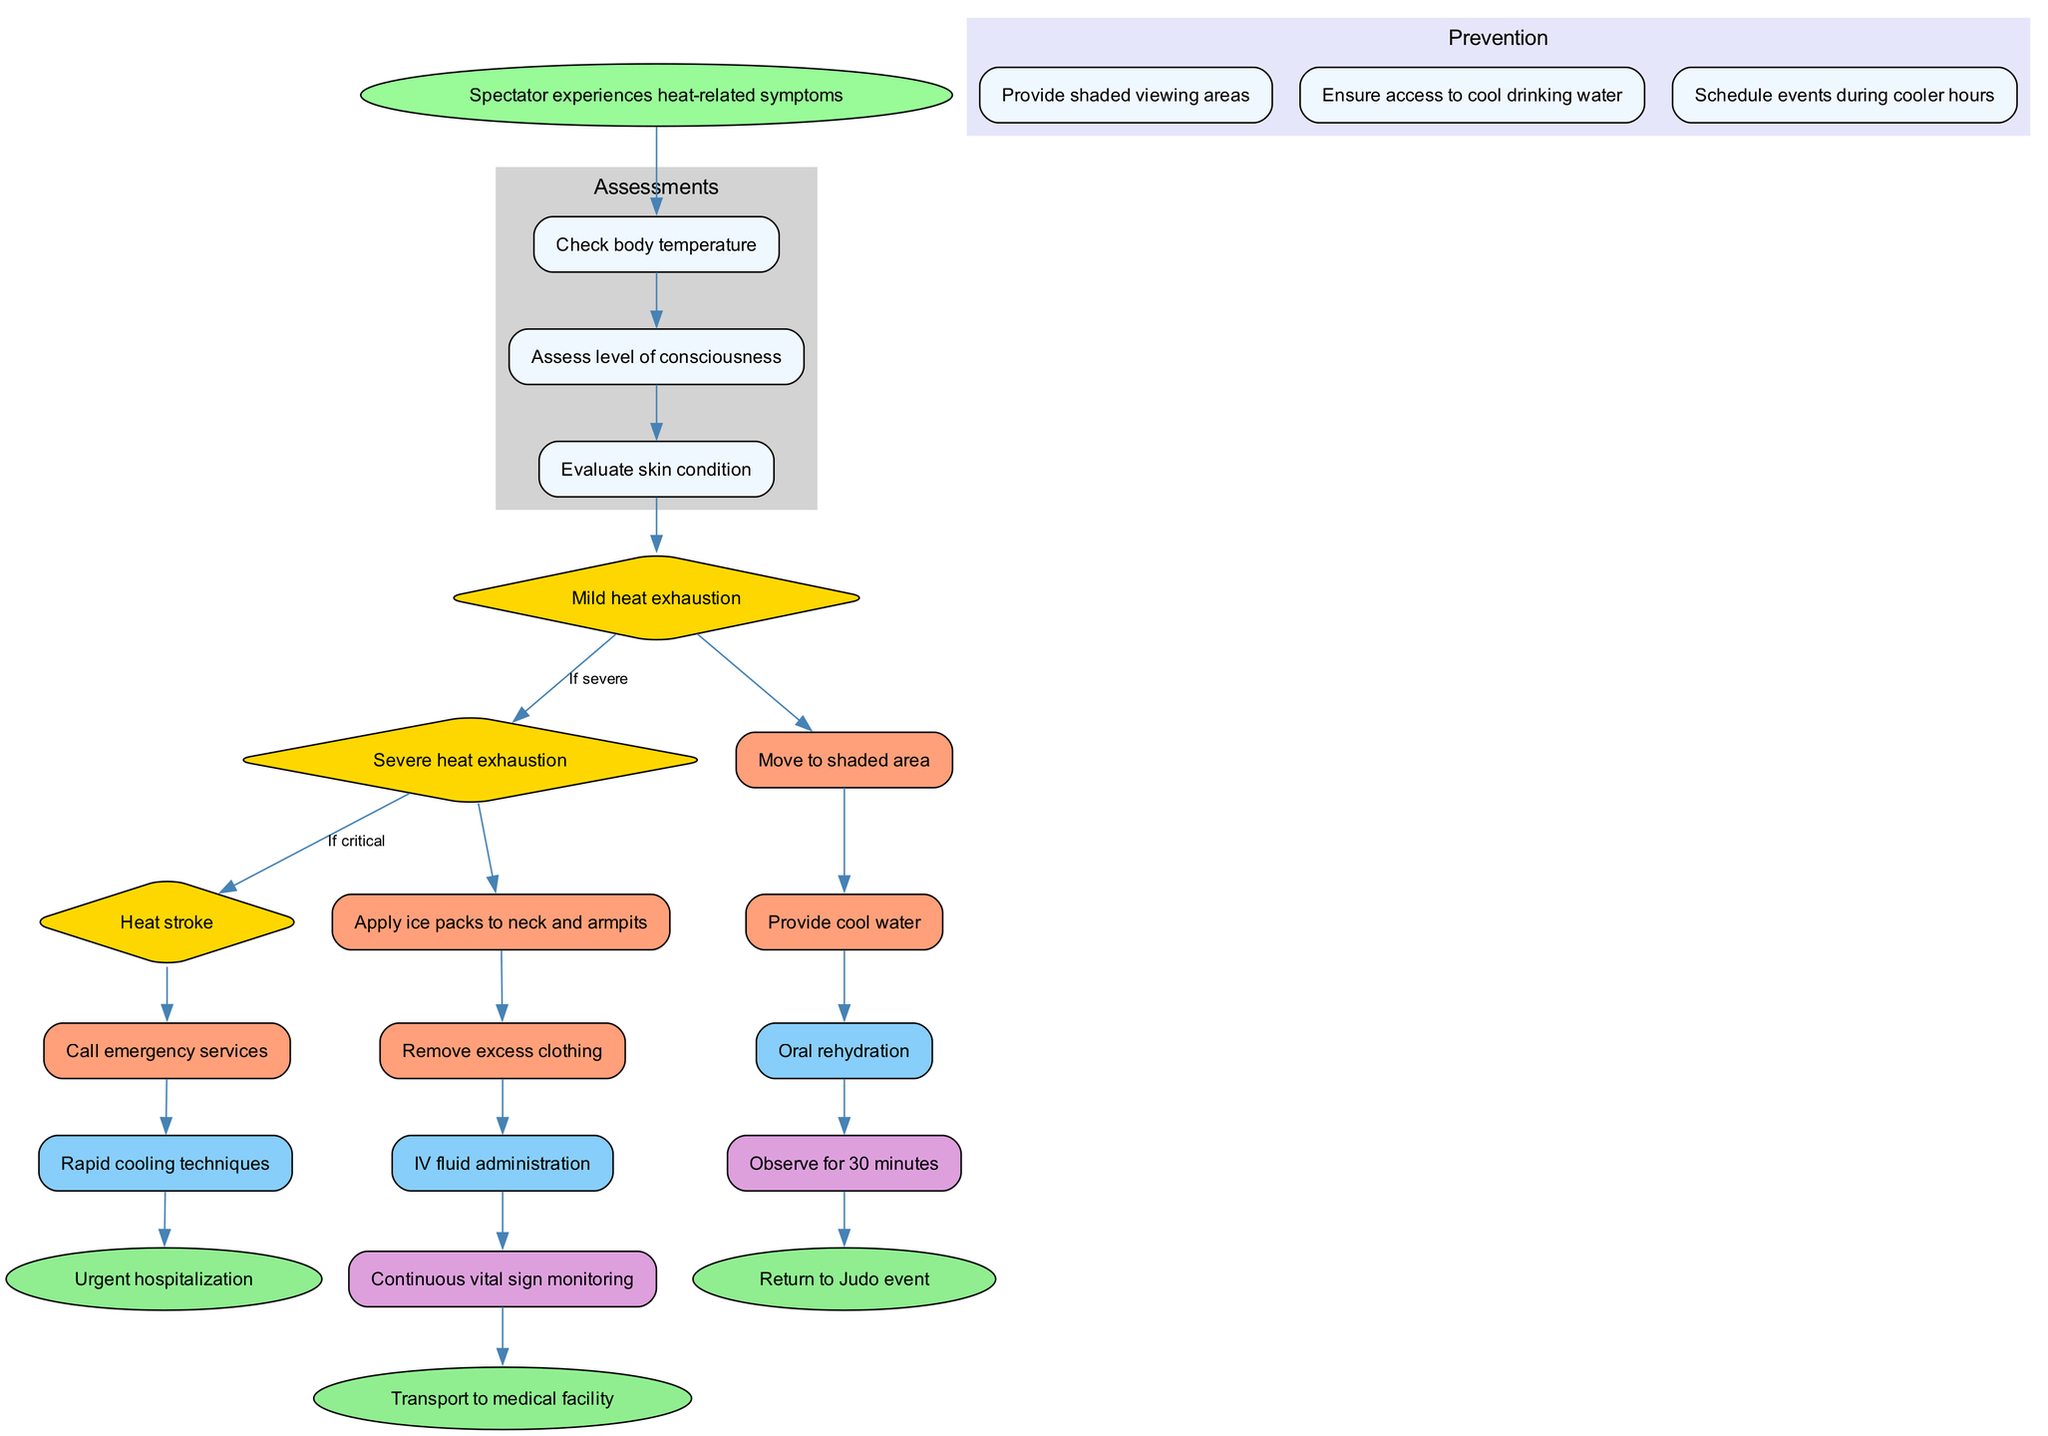What is the first action taken after the assessments? The first action following the assessments is providing cool water, which is directly connected to the assessment node in the pathway diagram.
Answer: Provide cool water How many different conditions are identified in the pathway? The pathway identifies three distinct conditions: mild heat exhaustion, severe heat exhaustion, and heat stroke, as indicated by the three diamond-shaped nodes.
Answer: Three What is the final outcome for a person experiencing heat stroke? The final outcome for a person experiencing heat stroke is urgent hospitalization, which is linked directly to the treatment and action taken for heat stroke.
Answer: Urgent hospitalization Which node is connected to continuous vital sign monitoring? Continuous vital sign monitoring is connected to the treatment node for IV fluid administration, indicating the need for ongoing observation following this treatment.
Answer: Continuous vital sign monitoring What condition prompts the action "apply ice packs to neck and armpits"? The action "apply ice packs to neck and armpits" is prompted when the condition is severe heat exhaustion, as shown in the connections from that condition node.
Answer: Severe heat exhaustion What are the prevention measures shown before any symptoms are experienced? The prevention measures outlined in the pathway include providing shaded viewing areas, ensuring access to cool drinking water, and scheduling events during cooler hours, which are all aimed at preventing heat-related illnesses.
Answer: Provide shaded viewing areas, Ensure access to cool drinking water, Schedule events during cooler hours How many assessments must be completed before determining a condition? Three assessments must be completed before determining a condition, as indicated by the sequence of three assessment nodes leading to the condition nodes.
Answer: Three What action is taken if mild heat exhaustion is confirmed? If mild heat exhaustion is confirmed, the first action is to move to a shaded area, directly linking this action to the mild heat exhaustion condition node.
Answer: Move to shaded area What type of recording is done first after an assessment? The first type of recording done after an assessment is to observe for 30 minutes, showcasing a monitoring step following the initial assessments and actions taken.
Answer: Observe for 30 minutes 